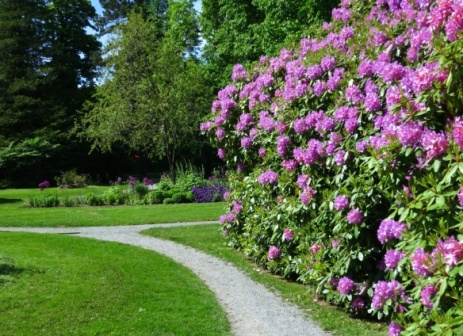What types of plants can be seen in this garden, and how do they contribute to the overall aesthetic? The garden features a variety of plants including large bushes with pink flowers likely rhododendrons, which provide a vibrant splash of color. There are also numerous green bushes and several types of trees that add depth and create a layered look. The white stone path is lined with smaller plants and grasses, which emphasize its winding route through the garden. This diversity in plant life not only enhances the garden's aesthetic but also encourages biodiversity, creating a habitat for various insects and birds. 